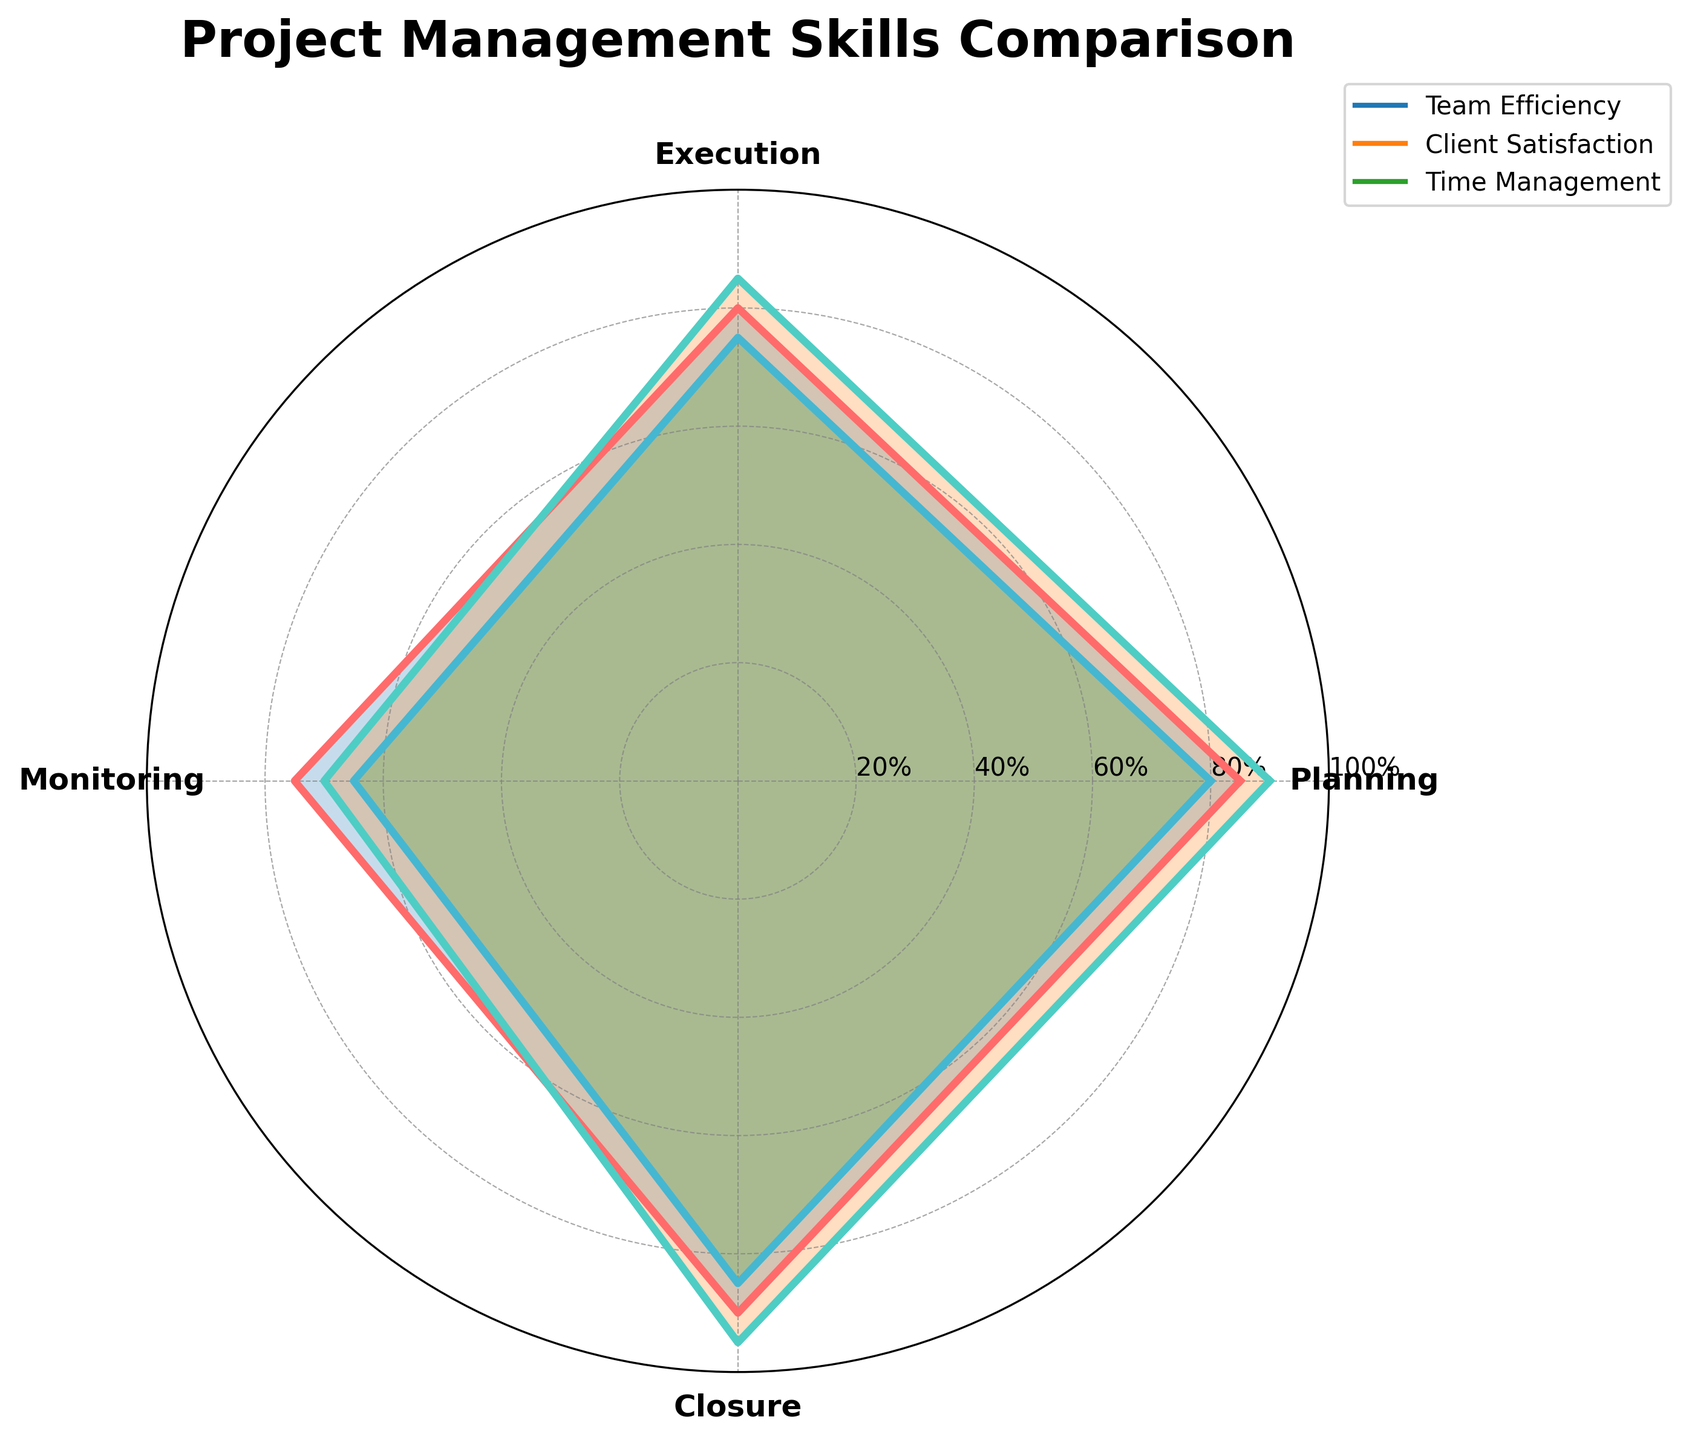What's the title of the plot? The title of the plot is found at the top center of the radar chart.
Answer: Project Management Skills Comparison How many groups are compared in the radar chart? By looking at the legend, we can see that there are three groups being compared.
Answer: 3 What skill does 'Client Satisfaction' score highest in? By observing the lines in the radar chart corresponding to 'Client Satisfaction', we see that the highest point on the radar chart for this group is on the 'Closure' axis.
Answer: Closure Which group is most efficient in 'Planning'? By comparing the points on the 'Planning' axis, we see that 'Client Satisfaction' has the highest value.
Answer: Client Satisfaction What is the lowest score for 'Time Management'? By analyzing the points corresponding to 'Time Management' in the radar chart, the lowest score is on the 'Monitoring' axis.
Answer: 65 What is the average score of 'Team Efficiency' across all skills? The scores for 'Team Efficiency' are 85, 80, 75, and 90. The average is calculated as (85 + 80 + 75 + 90) / 4 = 82.5.
Answer: 82.5 Who has the highest average score for 'Execution' and 'Closure' combined? The scores for 'Execution' and 'Closure' are: Team Efficiency (80+90=170), Client Satisfaction (85+95=180), Time Management (75+85=160). 'Client Satisfaction' has the highest combined score.
Answer: Client Satisfaction Which group has the least variation in their skills? To determine the least variation, compare the spread of values for each group. 'Client Satisfaction' varies from 70 to 95, 'Time Management' from 65 to 85, and 'Team Efficiency' from 75 to 90. 'Time Management' has the least range, thus the least variation.
Answer: Time Management What is the difference between 'Monitoring' scores of 'Team Efficiency' and 'Client Satisfaction'? The 'Monitoring' scores are 75 for 'Team Efficiency' and 70 for 'Client Satisfaction'. The difference is 75 - 70 = 5.
Answer: 5 